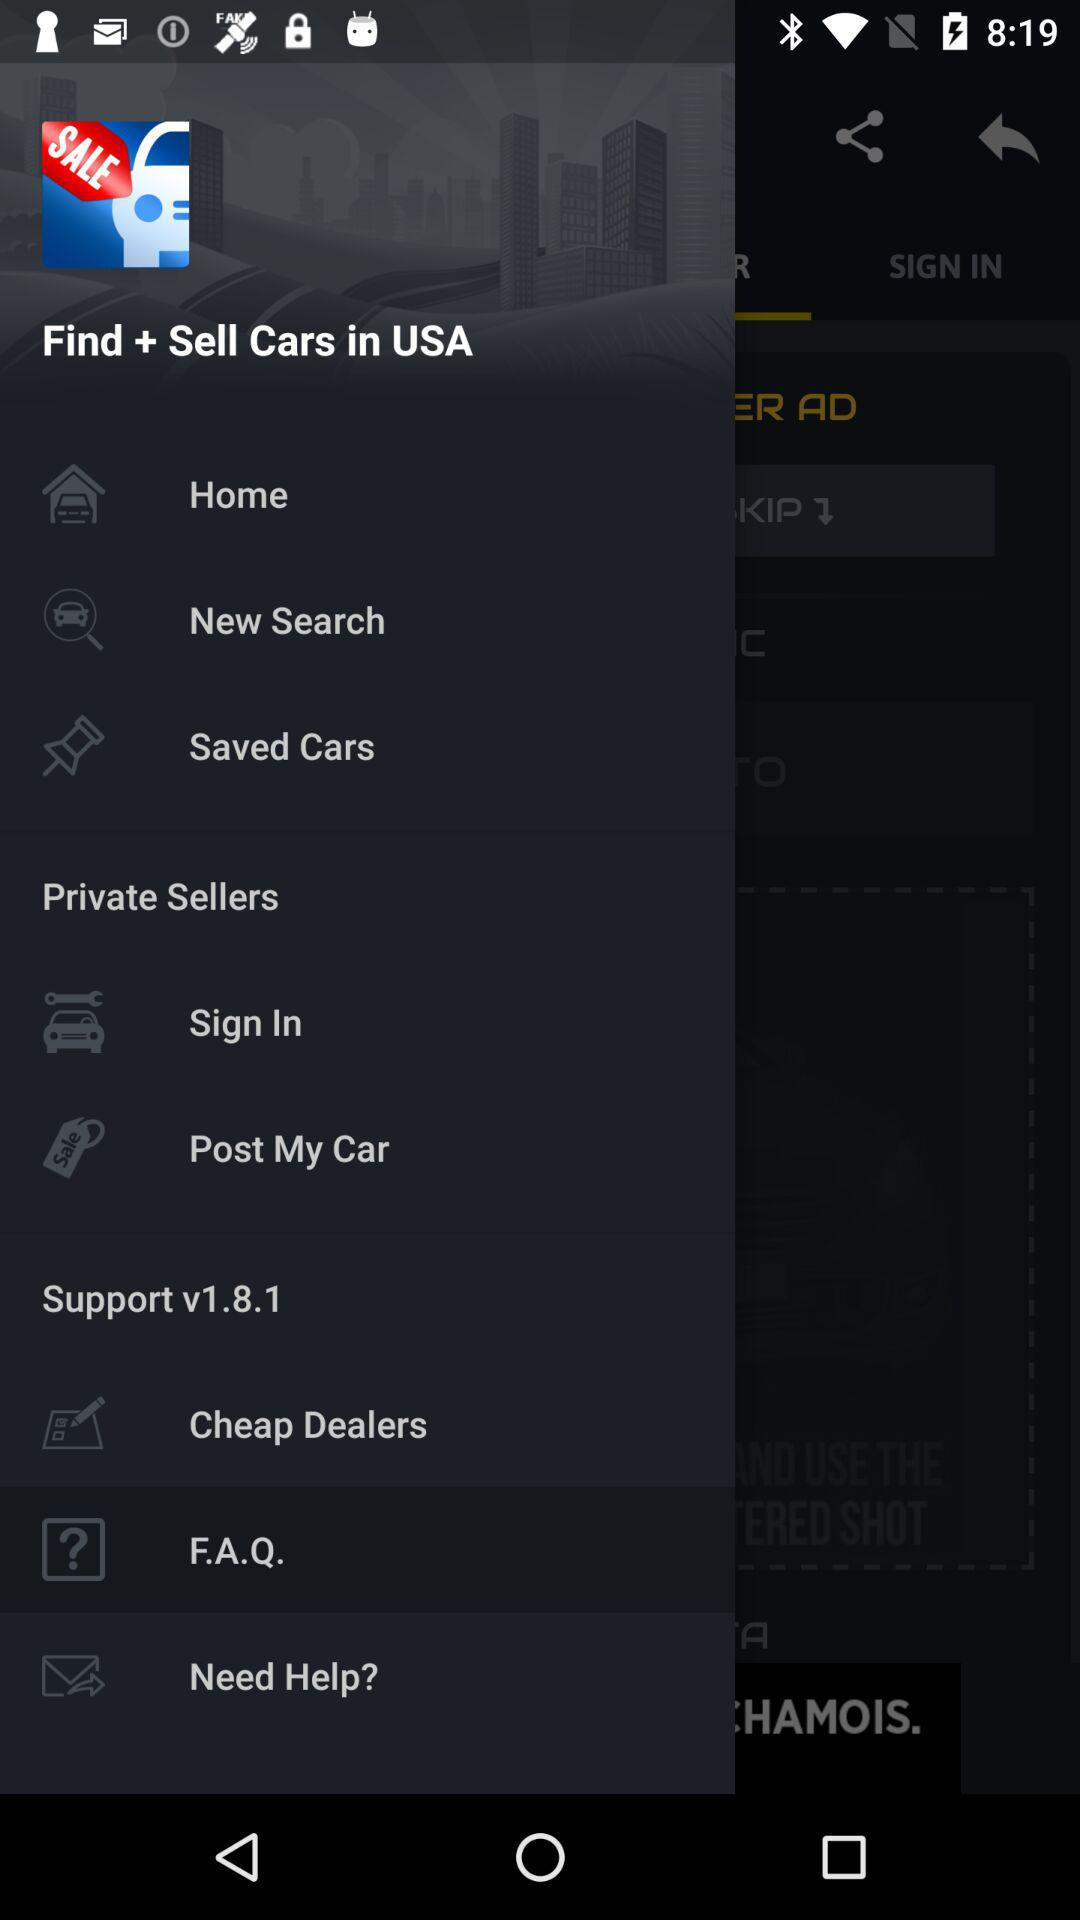Which tab is selected? The selected tab is "F.A.Q.". 